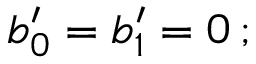Convert formula to latex. <formula><loc_0><loc_0><loc_500><loc_500>b _ { 0 } ^ { \prime } = b _ { 1 } ^ { \prime } = 0 \, ;</formula> 